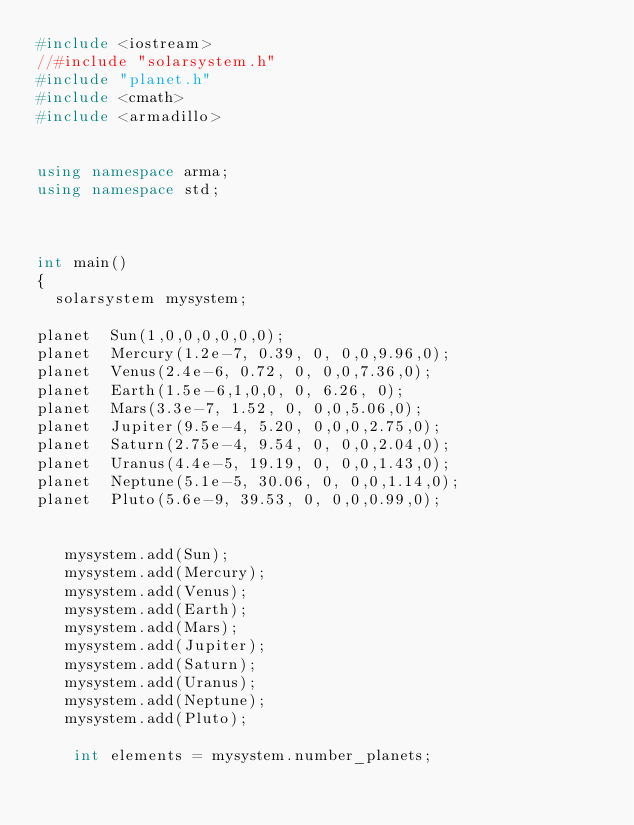Convert code to text. <code><loc_0><loc_0><loc_500><loc_500><_C++_>#include <iostream>
//#include "solarsystem.h"
#include "planet.h"
#include <cmath>
#include <armadillo>


using namespace arma;
using namespace std;



int main()
{
  solarsystem mysystem;

planet  Sun(1,0,0,0,0,0,0);
planet  Mercury(1.2e-7, 0.39, 0, 0,0,9.96,0);
planet  Venus(2.4e-6, 0.72, 0, 0,0,7.36,0);
planet  Earth(1.5e-6,1,0,0, 0, 6.26, 0);
planet  Mars(3.3e-7, 1.52, 0, 0,0,5.06,0);
planet  Jupiter(9.5e-4, 5.20, 0,0,0,2.75,0);
planet  Saturn(2.75e-4, 9.54, 0, 0,0,2.04,0);
planet  Uranus(4.4e-5, 19.19, 0, 0,0,1.43,0);
planet  Neptune(5.1e-5, 30.06, 0, 0,0,1.14,0);
planet  Pluto(5.6e-9, 39.53, 0, 0,0,0.99,0);


   mysystem.add(Sun);
   mysystem.add(Mercury);
   mysystem.add(Venus);
   mysystem.add(Earth);
   mysystem.add(Mars);
   mysystem.add(Jupiter);
   mysystem.add(Saturn);
   mysystem.add(Uranus);
   mysystem.add(Neptune);
   mysystem.add(Pluto);

    int elements = mysystem.number_planets;</code> 